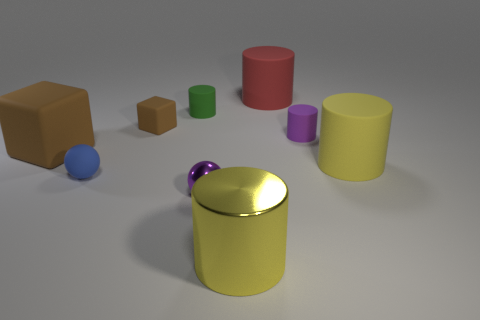There is a sphere that is made of the same material as the red thing; what color is it?
Offer a terse response. Blue. What number of other small spheres have the same material as the purple ball?
Offer a very short reply. 0. How many tiny green rubber cylinders are to the left of the big brown matte block?
Provide a short and direct response. 0. Are the cylinder to the left of the large shiny thing and the big cylinder in front of the purple metallic sphere made of the same material?
Provide a short and direct response. No. Is the number of big rubber things that are on the left side of the tiny green cylinder greater than the number of green matte cylinders to the right of the red matte cylinder?
Your answer should be very brief. Yes. What is the material of the thing that is the same color as the shiny ball?
Keep it short and to the point. Rubber. There is a object that is on the left side of the yellow metallic thing and in front of the small blue thing; what is its material?
Your answer should be very brief. Metal. Do the red cylinder and the tiny sphere right of the small green rubber cylinder have the same material?
Your answer should be very brief. No. How many objects are either tiny brown blocks or cubes that are on the right side of the blue sphere?
Ensure brevity in your answer.  1. There is a brown block that is to the left of the tiny blue object; is it the same size as the cylinder that is in front of the large yellow rubber cylinder?
Your answer should be compact. Yes. 